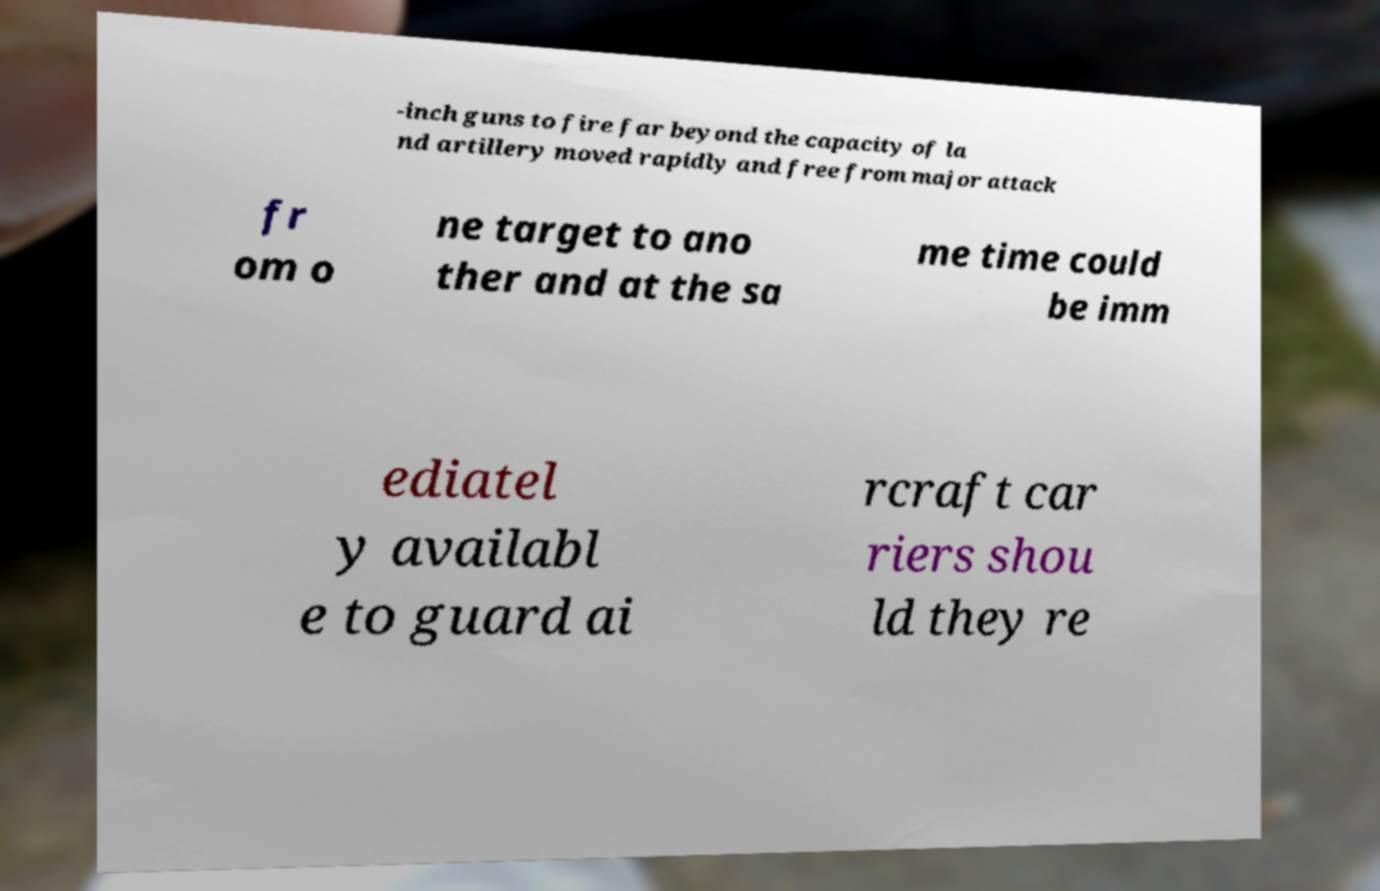Could you extract and type out the text from this image? -inch guns to fire far beyond the capacity of la nd artillery moved rapidly and free from major attack fr om o ne target to ano ther and at the sa me time could be imm ediatel y availabl e to guard ai rcraft car riers shou ld they re 